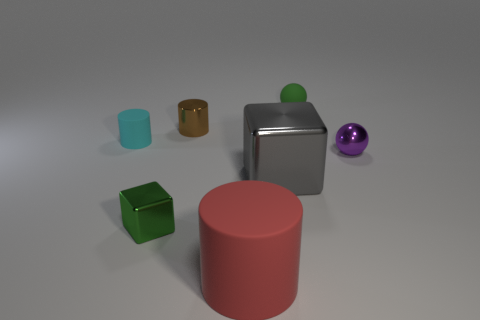Add 2 large green metal blocks. How many objects exist? 9 Subtract all cylinders. How many objects are left? 4 Add 5 small green metallic blocks. How many small green metallic blocks are left? 6 Add 5 big objects. How many big objects exist? 7 Subtract 0 green cylinders. How many objects are left? 7 Subtract all metallic blocks. Subtract all gray metal cubes. How many objects are left? 4 